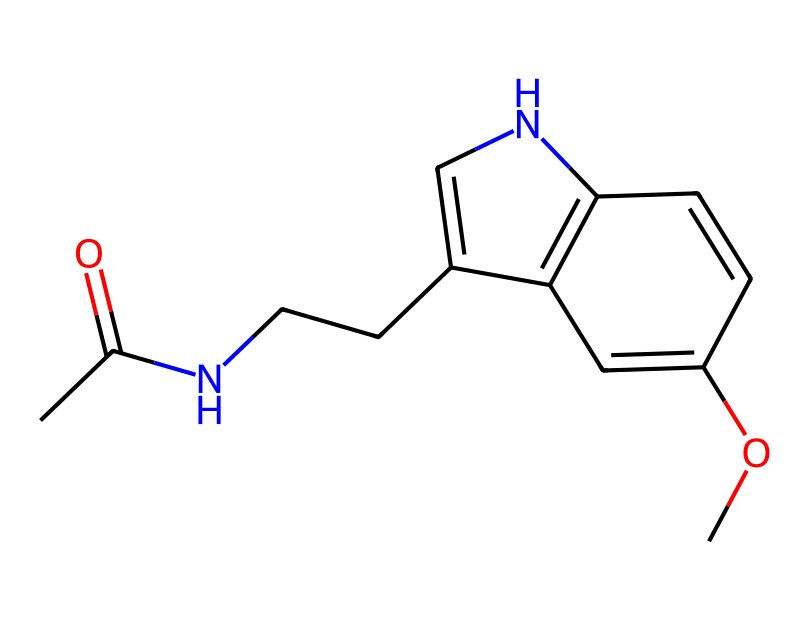How many carbon atoms are present in melatonin? By examining the SMILES representation, count the 'C' symbols which represent carbon atoms. In this chemical, there are 11 carbon atoms.
Answer: 11 What is the functional group associated with melatonin? Analyzing the structure, the 'N' symbolizes an amine group, while the 'C(=O)' indicates a carbonyl functional group. Together, these form the amide functional group.
Answer: amide How many nitrogen atoms are found in melatonin? The SMILES notation includes two 'N' symbols, which represent the nitrogen atoms within the molecular structure. Thus, melatonin contains two nitrogen atoms.
Answer: 2 What effect does melatonin have on productivity? Melatonin primarily regulates the sleep-wake cycle, influencing sleep quality and therefore impacts overall productivity.
Answer: regulates sleep What is the molecular weight of melatonin? Based on the molecular formula derived from the SMILES (C13H16N2O2), calculate the molecular weight by summing the atomic weights of each element: (13*12.01) + (16*1.008) + (2*14.01) + (2*16.00) which results in approximately 232.3 g/mol.
Answer: 232.3 g/mol How does the structure of melatonin relate to its function as a hormone? Melatonin's specific structure, including the indole ring and the amide group, enables it to interact with melatonin receptors in the body, mediating its role in regulating circadian rhythms and sleep patterns.
Answer: interacts with receptors 